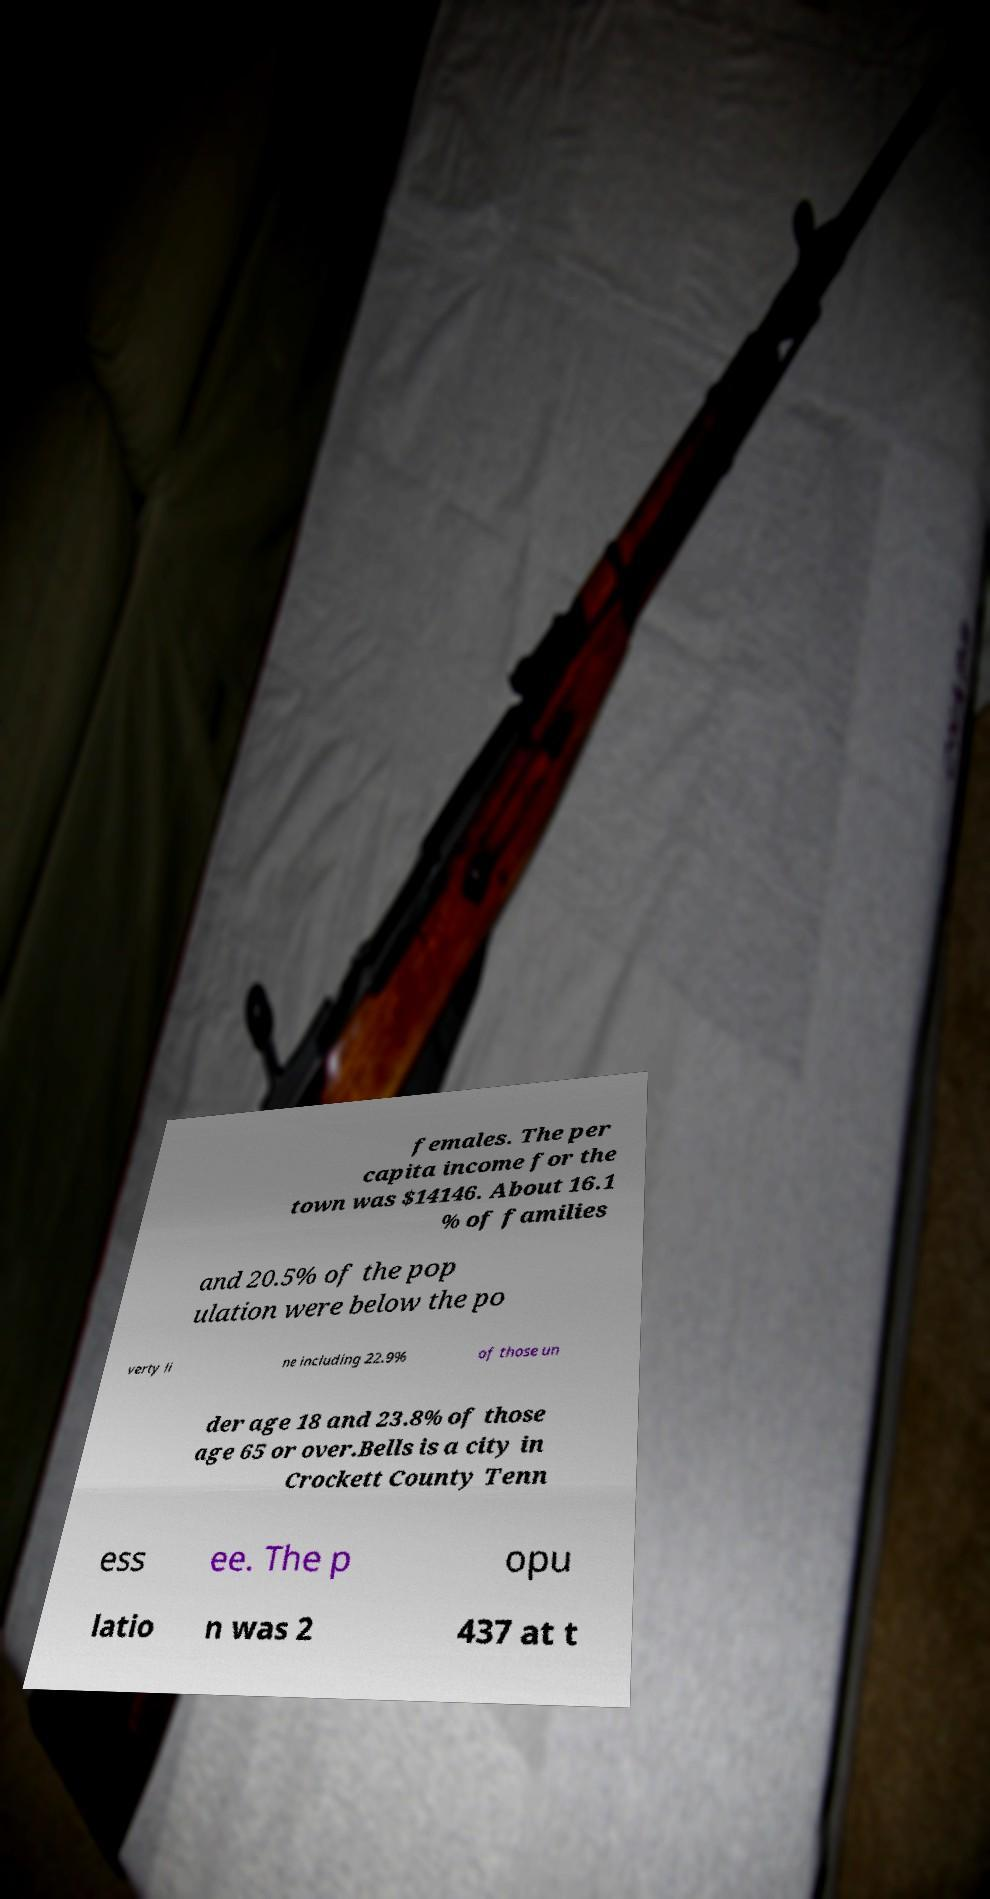There's text embedded in this image that I need extracted. Can you transcribe it verbatim? females. The per capita income for the town was $14146. About 16.1 % of families and 20.5% of the pop ulation were below the po verty li ne including 22.9% of those un der age 18 and 23.8% of those age 65 or over.Bells is a city in Crockett County Tenn ess ee. The p opu latio n was 2 437 at t 